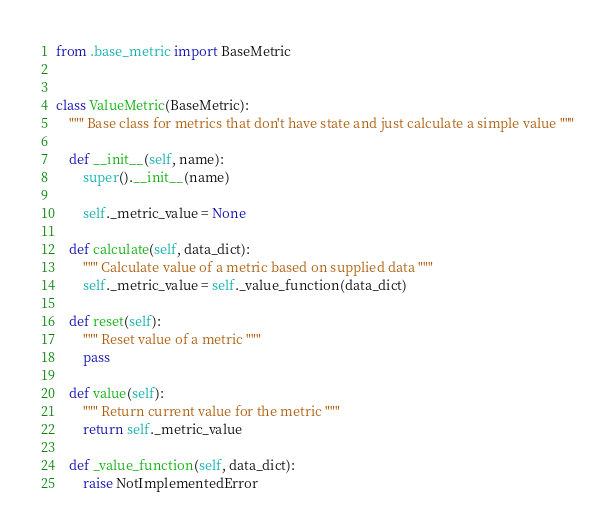<code> <loc_0><loc_0><loc_500><loc_500><_Python_>from .base_metric import BaseMetric


class ValueMetric(BaseMetric):
    """ Base class for metrics that don't have state and just calculate a simple value """

    def __init__(self, name):
        super().__init__(name)

        self._metric_value = None

    def calculate(self, data_dict):
        """ Calculate value of a metric based on supplied data """
        self._metric_value = self._value_function(data_dict)

    def reset(self):
        """ Reset value of a metric """
        pass

    def value(self):
        """ Return current value for the metric """
        return self._metric_value

    def _value_function(self, data_dict):
        raise NotImplementedError

</code> 